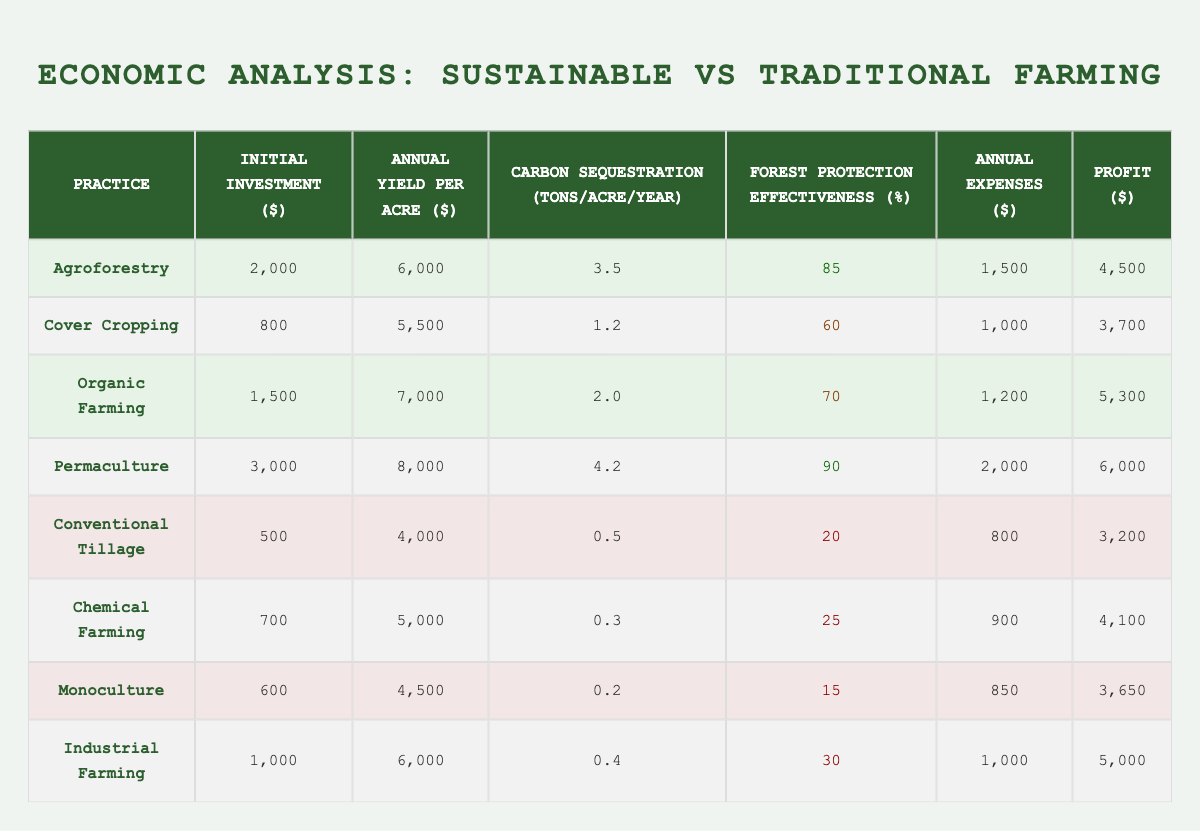What is the initial investment for Permaculture? The initial investment for Permaculture is listed in the table under the "Initial Investment ($)" column. It shows $3,000 for Permaculture.
Answer: 3000 Which sustainable farming practice has the highest annual yield per acre? By examining the "Annual Yield per Acre ($)" column, Permaculture shows the highest yield at $8,000 per acre compared to other sustainable practices.
Answer: 8000 What is the profit of Traditional Tillage? The profit for Traditional Tillage is found in the "Profit ($)" column and is $3,200.
Answer: 3200 How much more carbon sequestration does Agroforestry achieve compared to Conventional Tillage? First, find the carbon sequestration values: Agroforestry is 3.5 tons/acre/year and Conventional Tillage is 0.5 tons/acre/year. Then, subtract 0.5 from 3.5, resulting in 3.0 tons/acre/year more for Agroforestry.
Answer: 3.0 What is the total profit for all sustainable farming practices? The profits for sustainable practices are $4,500, $3,700, $5,300, and $6,000. Adding these together: 4,500 + 3,700 + 5,300 + 6,000 = 19,500.
Answer: 19500 Does Organic Farming have a higher profit than Chemical Farming? The profit for Organic Farming is $5,300 and for Chemical Farming is $4,100. Since 5,300 is greater than 4,100, the answer is yes.
Answer: Yes What is the average carbon sequestration rate for traditional farming practices? The carbon sequestration rates for traditional practices are 0.5, 0.3, 0.2, and 0.4 tons/acre/year. Summing these gives 1.4, then dividing by 4 (the number of practices): 1.4/4 = 0.35 tons/acre/year.
Answer: 0.35 Which sustainable farming practice has the best forest protection effectiveness? Comparing the "Forest Protection Effectiveness (%)" column, Permaculture has the highest effectiveness at 90%, making it the best in this regard.
Answer: 90 What is the profit difference between the best and worst sustainable farming practices? The highest profit among sustainable practices is $6,000 (Permaculture), and the lowest is $3,700 (Cover Cropping). The difference is calculated as 6,000 - 3,700 = 2,300.
Answer: 2300 Is the annual yield per acre for Monoculture equal to or greater than that of Chemical Farming? The annual yield for Monoculture is $4,500 while for Chemical Farming it is $5,000. Since $4,500 is less than $5,000, the answer is no.
Answer: No 